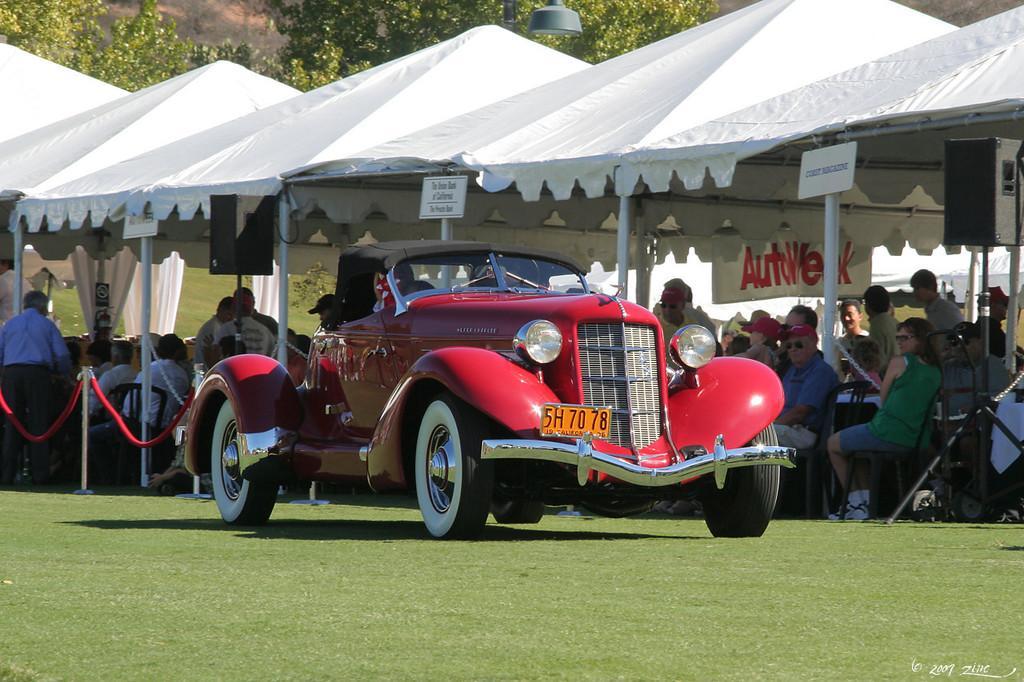Describe this image in one or two sentences. In the image there is a vehicle kept on the ground and behind the vehicle there are few tents, under those tents there are many people, in the background there are few trees. 